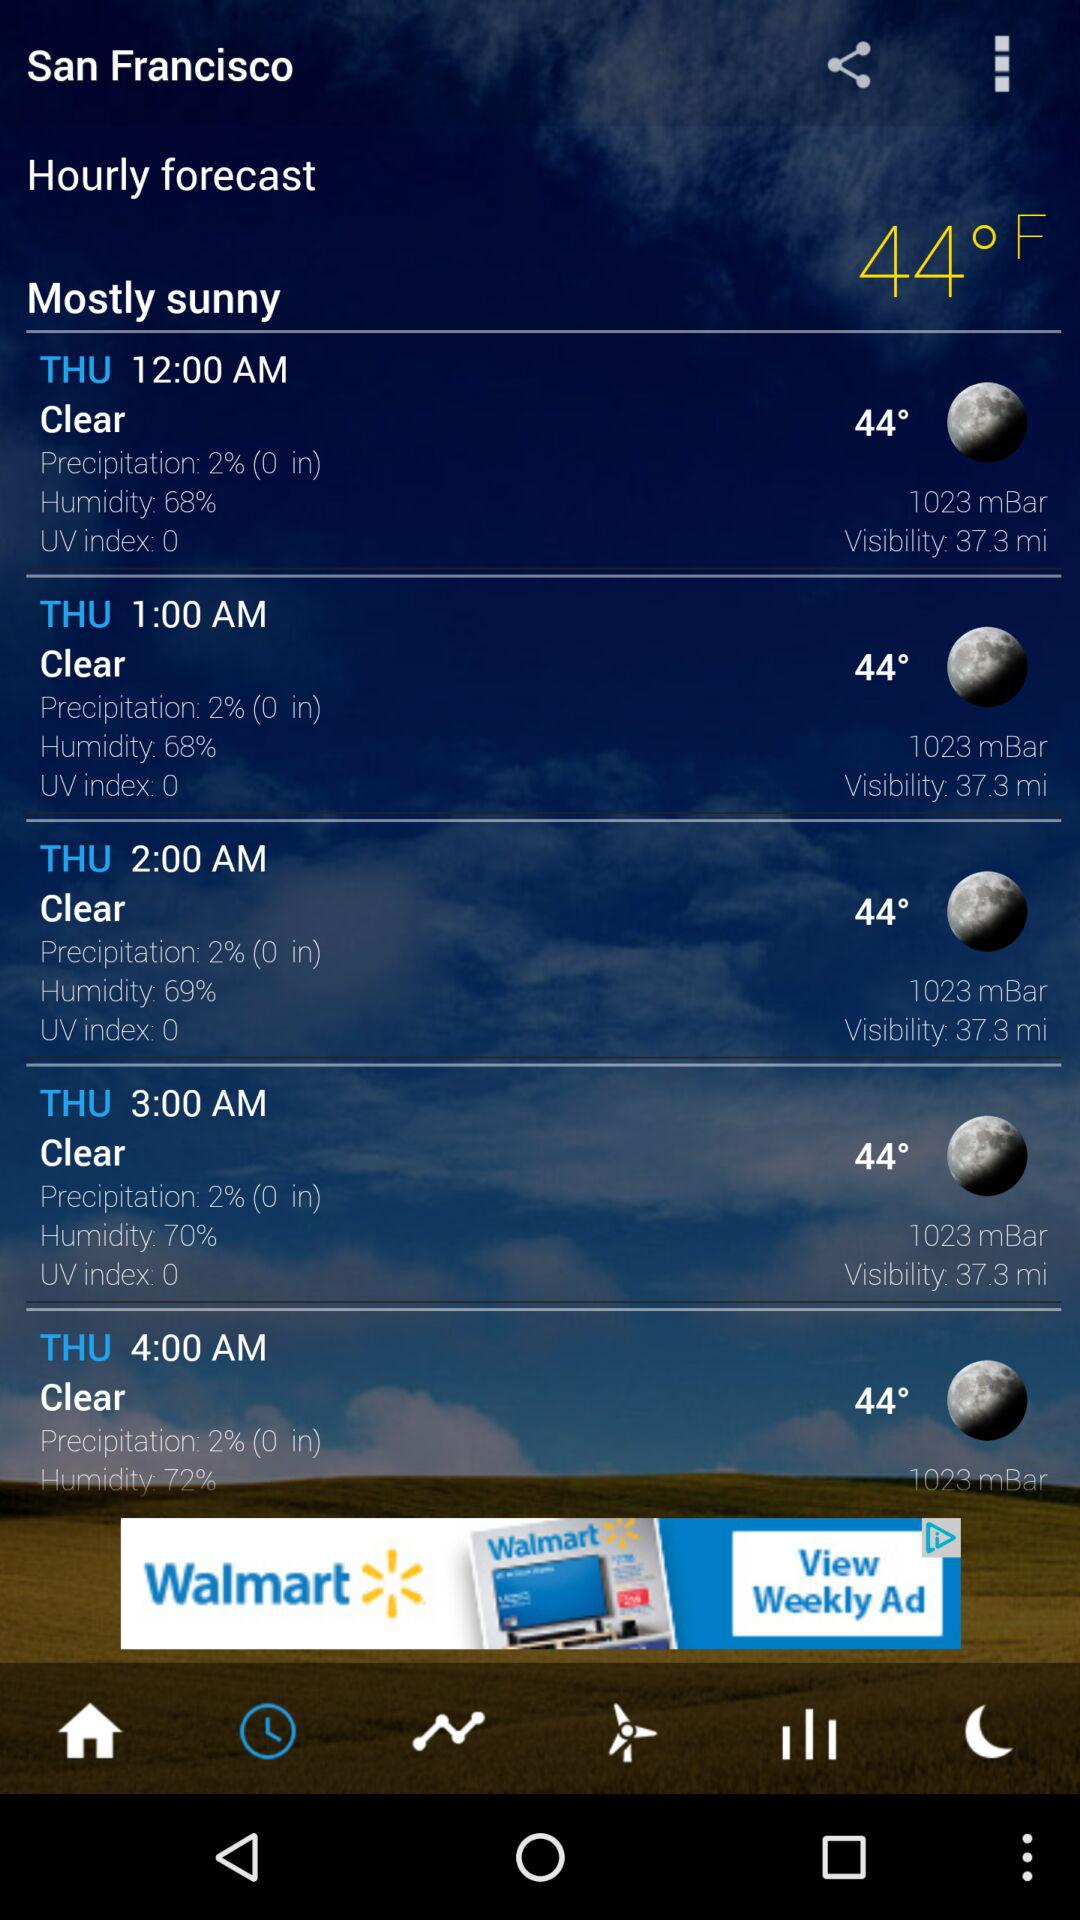What is the temperature at 12:00 a.m.? The temperature is 44°. 